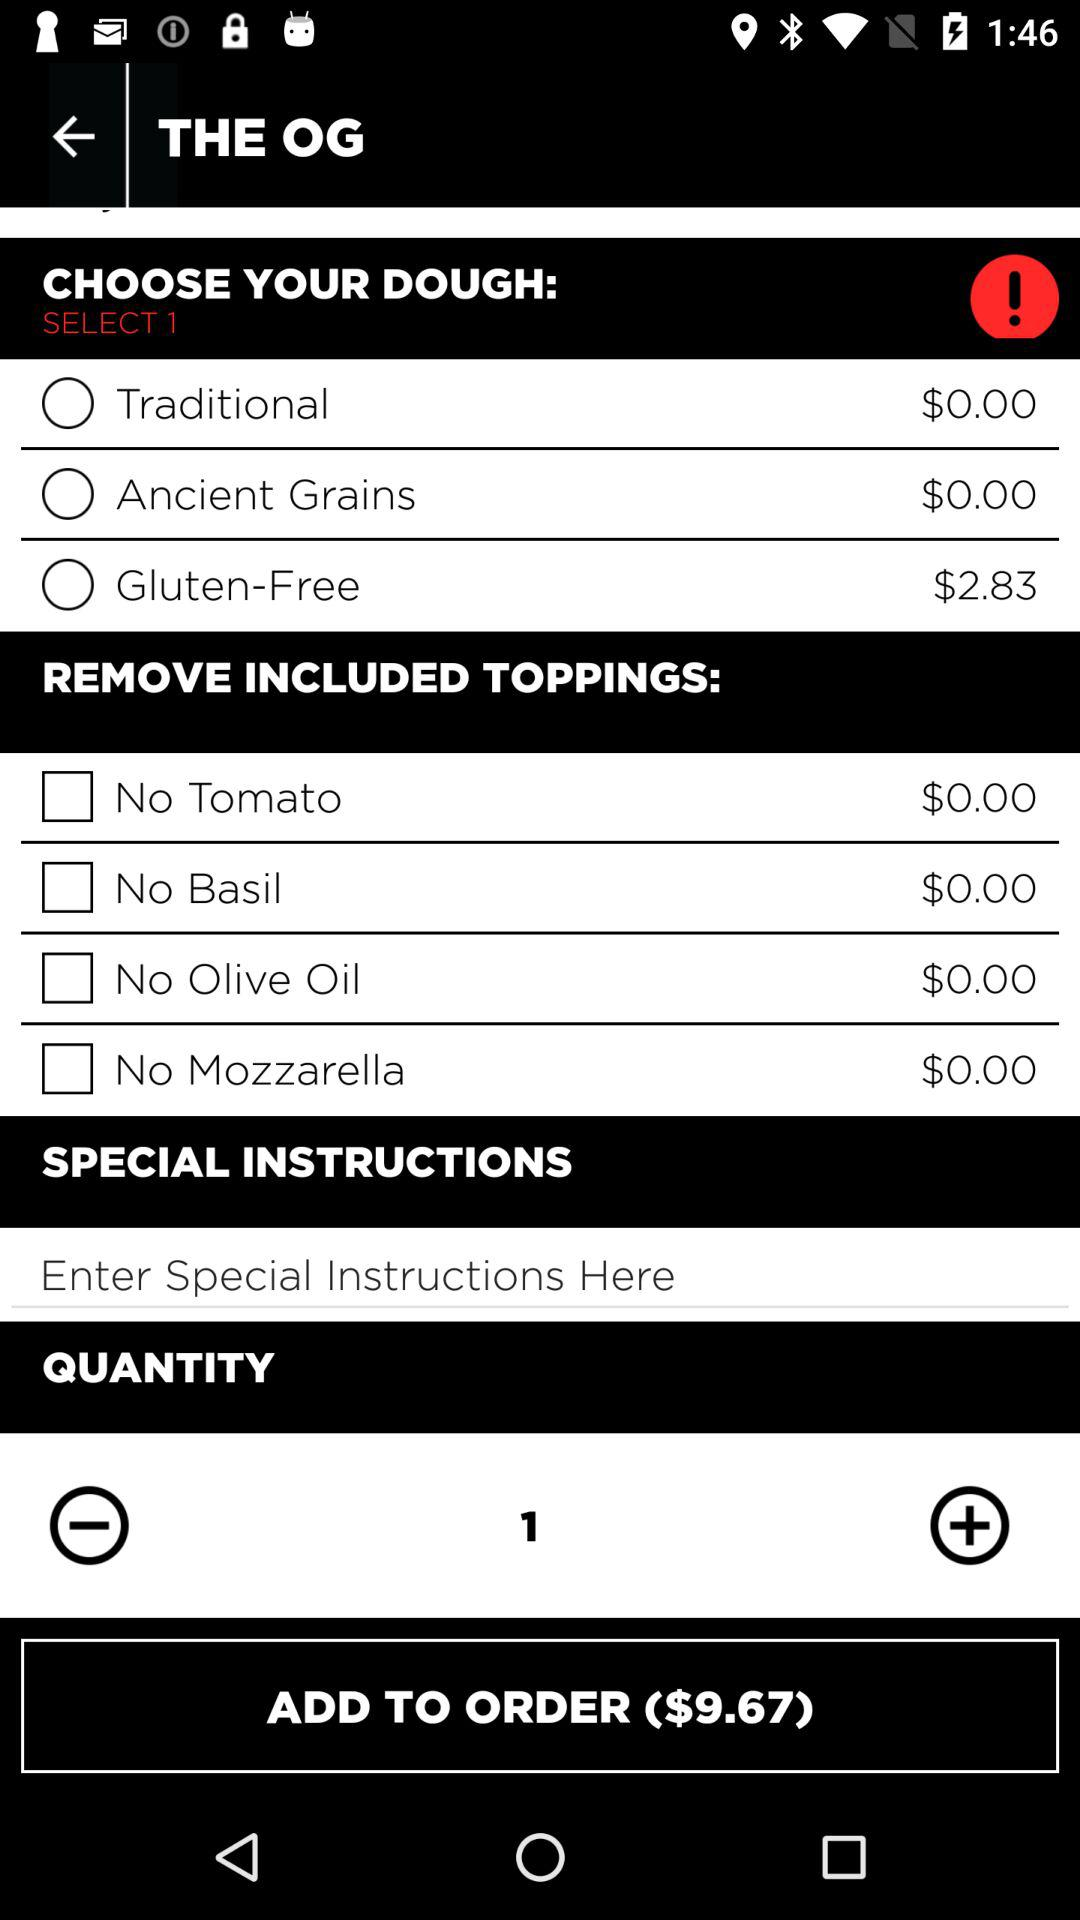What is the price for gluten-free dough? The price is $2.83. 